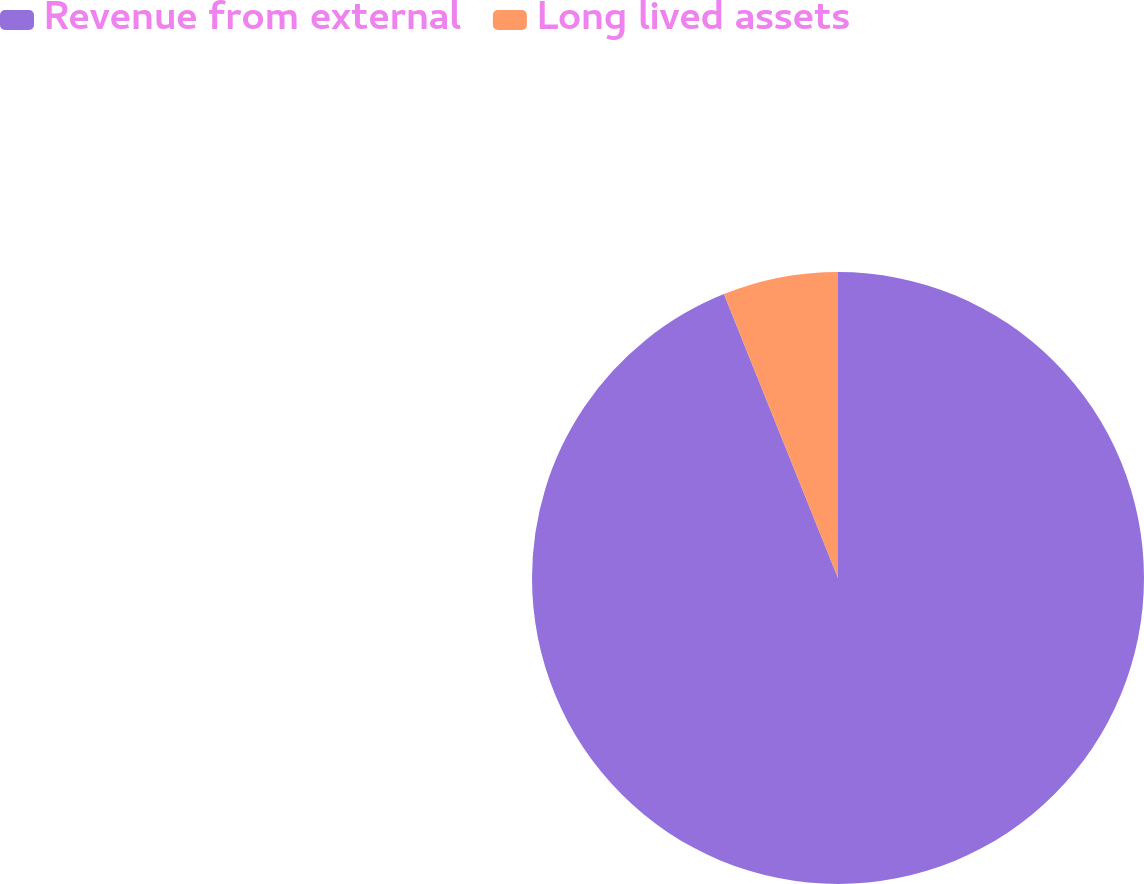<chart> <loc_0><loc_0><loc_500><loc_500><pie_chart><fcel>Revenue from external<fcel>Long lived assets<nl><fcel>93.92%<fcel>6.08%<nl></chart> 